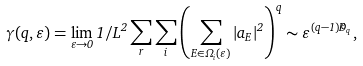Convert formula to latex. <formula><loc_0><loc_0><loc_500><loc_500>\gamma ( q , \varepsilon ) = \lim _ { \varepsilon \to 0 } 1 / L ^ { 2 } \sum _ { r } \sum _ { i } \left ( \sum _ { E \in \Omega _ { i } ( \varepsilon ) } | a _ { E } | ^ { 2 } \right ) ^ { q } \sim \varepsilon ^ { ( q - 1 ) \widetilde { D } _ { q } } ,</formula> 